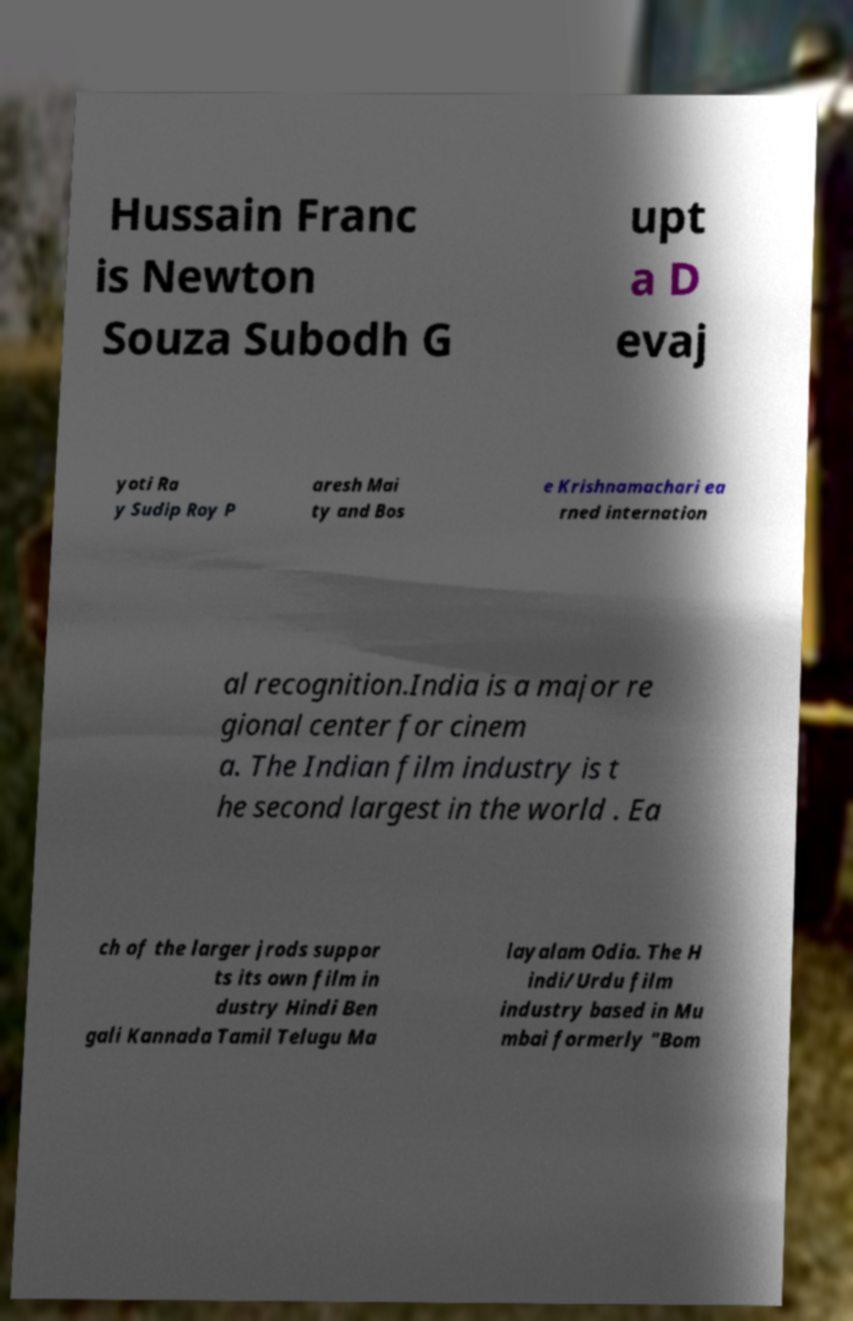Can you read and provide the text displayed in the image?This photo seems to have some interesting text. Can you extract and type it out for me? Hussain Franc is Newton Souza Subodh G upt a D evaj yoti Ra y Sudip Roy P aresh Mai ty and Bos e Krishnamachari ea rned internation al recognition.India is a major re gional center for cinem a. The Indian film industry is t he second largest in the world . Ea ch of the larger jrods suppor ts its own film in dustry Hindi Ben gali Kannada Tamil Telugu Ma layalam Odia. The H indi/Urdu film industry based in Mu mbai formerly "Bom 